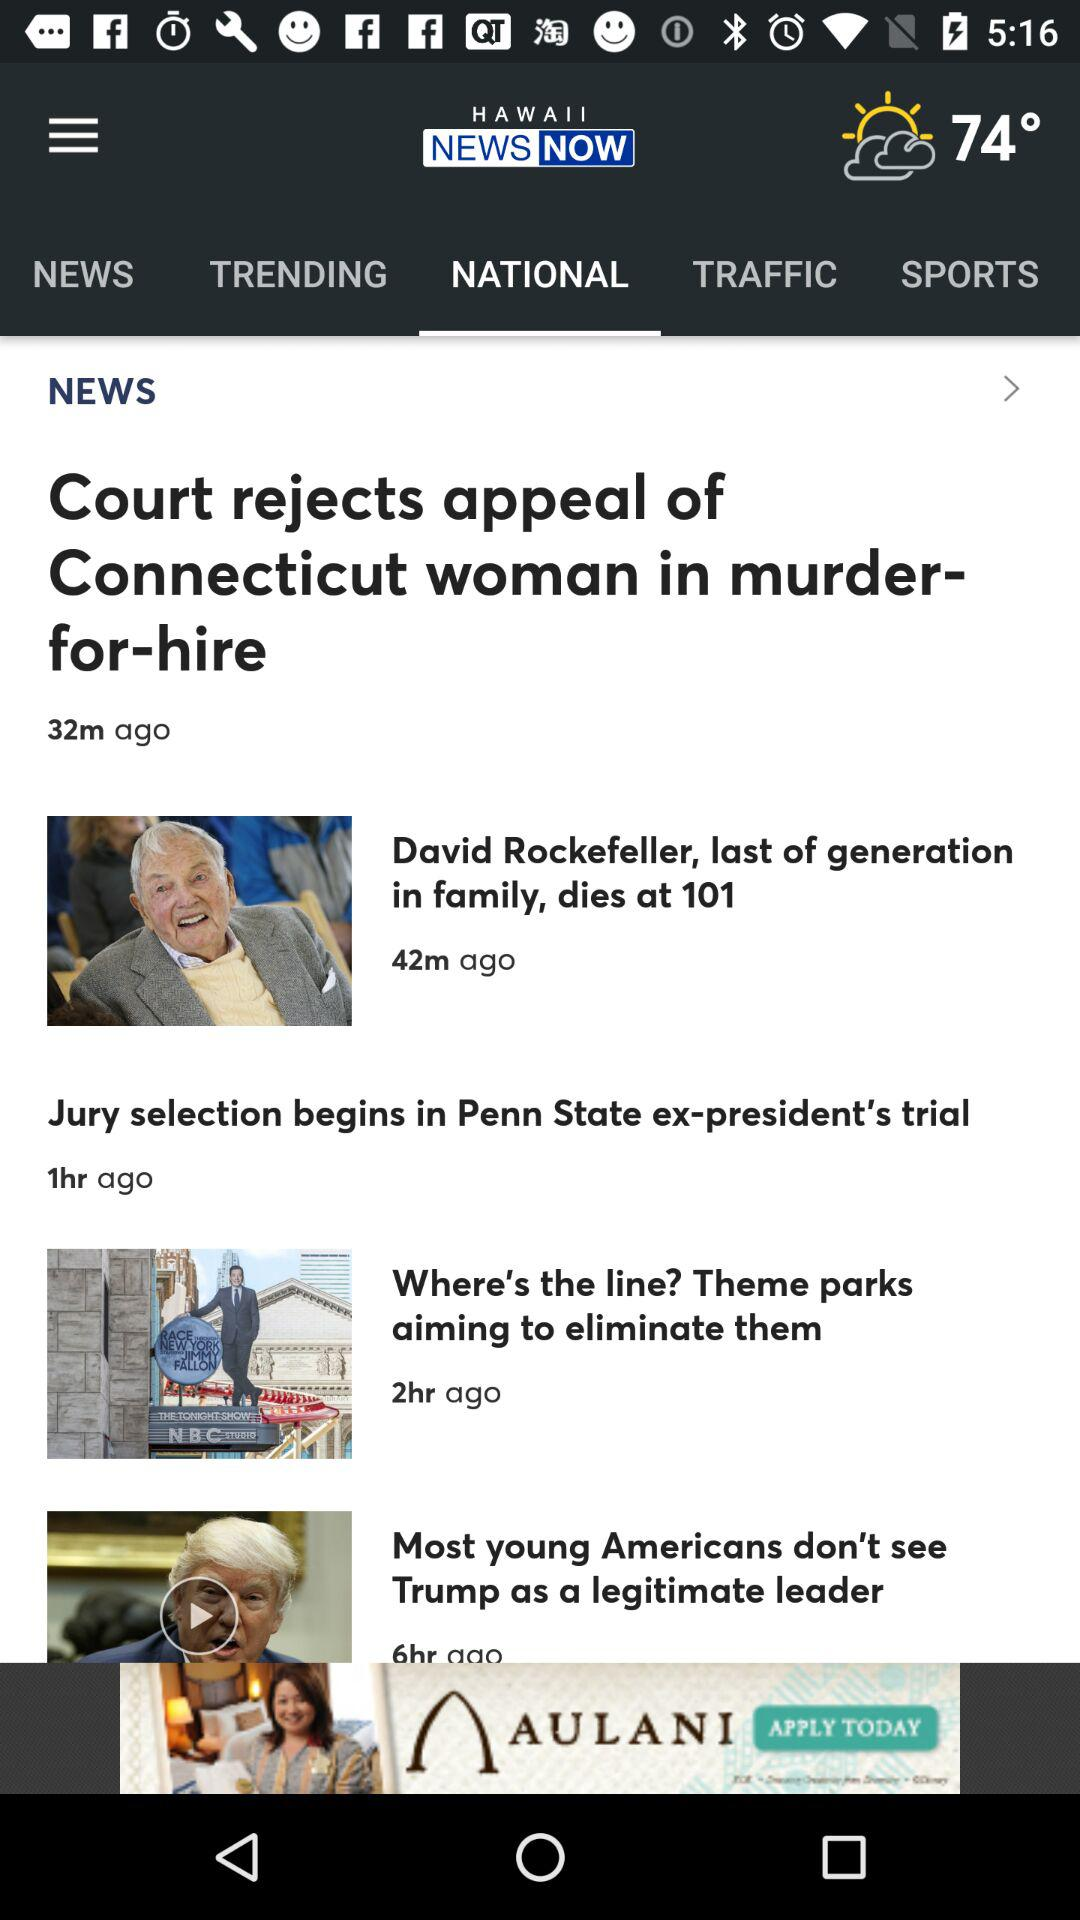How long ago was the news "Where's the line? Theme parks aiming to eliminate them" posted? The news "Where's the line? Theme parks aiming to eliminate them" was posted 2 hours ago. 